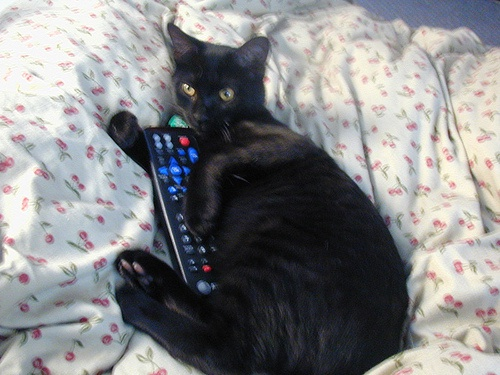Describe the objects in this image and their specific colors. I can see bed in white, lightgray, and darkgray tones, cat in white, black, gray, and darkgray tones, and remote in white, black, navy, gray, and blue tones in this image. 